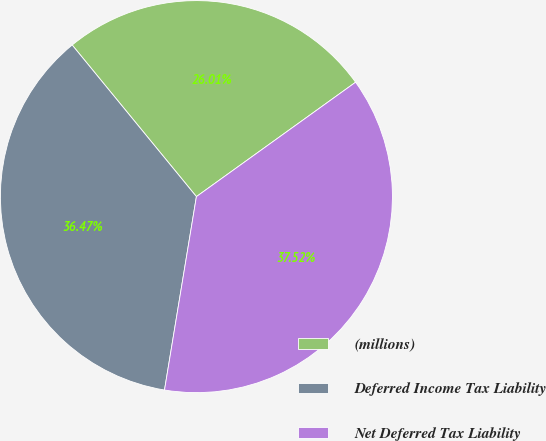Convert chart to OTSL. <chart><loc_0><loc_0><loc_500><loc_500><pie_chart><fcel>(millions)<fcel>Deferred Income Tax Liability<fcel>Net Deferred Tax Liability<nl><fcel>26.01%<fcel>36.47%<fcel>37.52%<nl></chart> 